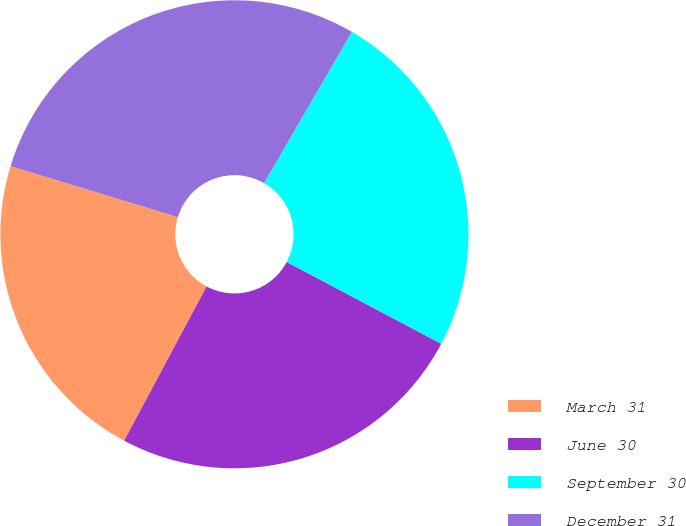<chart> <loc_0><loc_0><loc_500><loc_500><pie_chart><fcel>March 31<fcel>June 30<fcel>September 30<fcel>December 31<nl><fcel>21.89%<fcel>25.06%<fcel>24.38%<fcel>28.66%<nl></chart> 